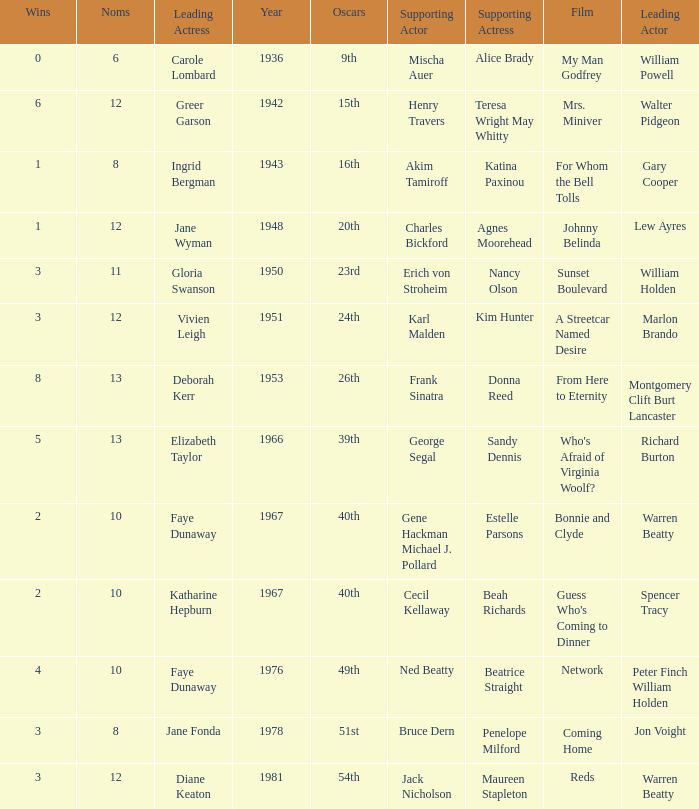Give me the full table as a dictionary. {'header': ['Wins', 'Noms', 'Leading Actress', 'Year', 'Oscars', 'Supporting Actor', 'Supporting Actress', 'Film', 'Leading Actor'], 'rows': [['0', '6', 'Carole Lombard', '1936', '9th', 'Mischa Auer', 'Alice Brady', 'My Man Godfrey', 'William Powell'], ['6', '12', 'Greer Garson', '1942', '15th', 'Henry Travers', 'Teresa Wright May Whitty', 'Mrs. Miniver', 'Walter Pidgeon'], ['1', '8', 'Ingrid Bergman', '1943', '16th', 'Akim Tamiroff', 'Katina Paxinou', 'For Whom the Bell Tolls', 'Gary Cooper'], ['1', '12', 'Jane Wyman', '1948', '20th', 'Charles Bickford', 'Agnes Moorehead', 'Johnny Belinda', 'Lew Ayres'], ['3', '11', 'Gloria Swanson', '1950', '23rd', 'Erich von Stroheim', 'Nancy Olson', 'Sunset Boulevard', 'William Holden'], ['3', '12', 'Vivien Leigh', '1951', '24th', 'Karl Malden', 'Kim Hunter', 'A Streetcar Named Desire', 'Marlon Brando'], ['8', '13', 'Deborah Kerr', '1953', '26th', 'Frank Sinatra', 'Donna Reed', 'From Here to Eternity', 'Montgomery Clift Burt Lancaster'], ['5', '13', 'Elizabeth Taylor', '1966', '39th', 'George Segal', 'Sandy Dennis', "Who's Afraid of Virginia Woolf?", 'Richard Burton'], ['2', '10', 'Faye Dunaway', '1967', '40th', 'Gene Hackman Michael J. Pollard', 'Estelle Parsons', 'Bonnie and Clyde', 'Warren Beatty'], ['2', '10', 'Katharine Hepburn', '1967', '40th', 'Cecil Kellaway', 'Beah Richards', "Guess Who's Coming to Dinner", 'Spencer Tracy'], ['4', '10', 'Faye Dunaway', '1976', '49th', 'Ned Beatty', 'Beatrice Straight', 'Network', 'Peter Finch William Holden'], ['3', '8', 'Jane Fonda', '1978', '51st', 'Bruce Dern', 'Penelope Milford', 'Coming Home', 'Jon Voight'], ['3', '12', 'Diane Keaton', '1981', '54th', 'Jack Nicholson', 'Maureen Stapleton', 'Reds', 'Warren Beatty']]} Who was the leading actress in a film with Warren Beatty as the leading actor and also at the 40th Oscars? Faye Dunaway. 